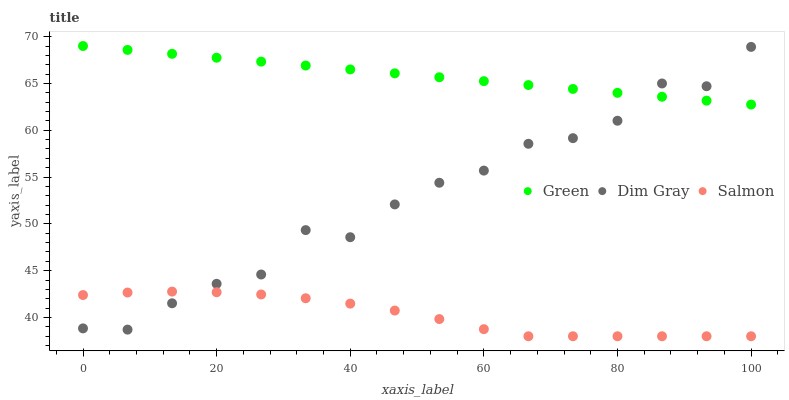Does Salmon have the minimum area under the curve?
Answer yes or no. Yes. Does Green have the maximum area under the curve?
Answer yes or no. Yes. Does Dim Gray have the minimum area under the curve?
Answer yes or no. No. Does Dim Gray have the maximum area under the curve?
Answer yes or no. No. Is Green the smoothest?
Answer yes or no. Yes. Is Dim Gray the roughest?
Answer yes or no. Yes. Is Dim Gray the smoothest?
Answer yes or no. No. Is Green the roughest?
Answer yes or no. No. Does Salmon have the lowest value?
Answer yes or no. Yes. Does Dim Gray have the lowest value?
Answer yes or no. No. Does Green have the highest value?
Answer yes or no. Yes. Does Dim Gray have the highest value?
Answer yes or no. No. Is Salmon less than Green?
Answer yes or no. Yes. Is Green greater than Salmon?
Answer yes or no. Yes. Does Salmon intersect Dim Gray?
Answer yes or no. Yes. Is Salmon less than Dim Gray?
Answer yes or no. No. Is Salmon greater than Dim Gray?
Answer yes or no. No. Does Salmon intersect Green?
Answer yes or no. No. 